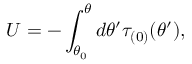<formula> <loc_0><loc_0><loc_500><loc_500>U = - \int _ { \theta _ { 0 } } ^ { \theta } d \theta ^ { \prime } \tau _ { ( 0 ) } ( \theta ^ { \prime } ) ,</formula> 